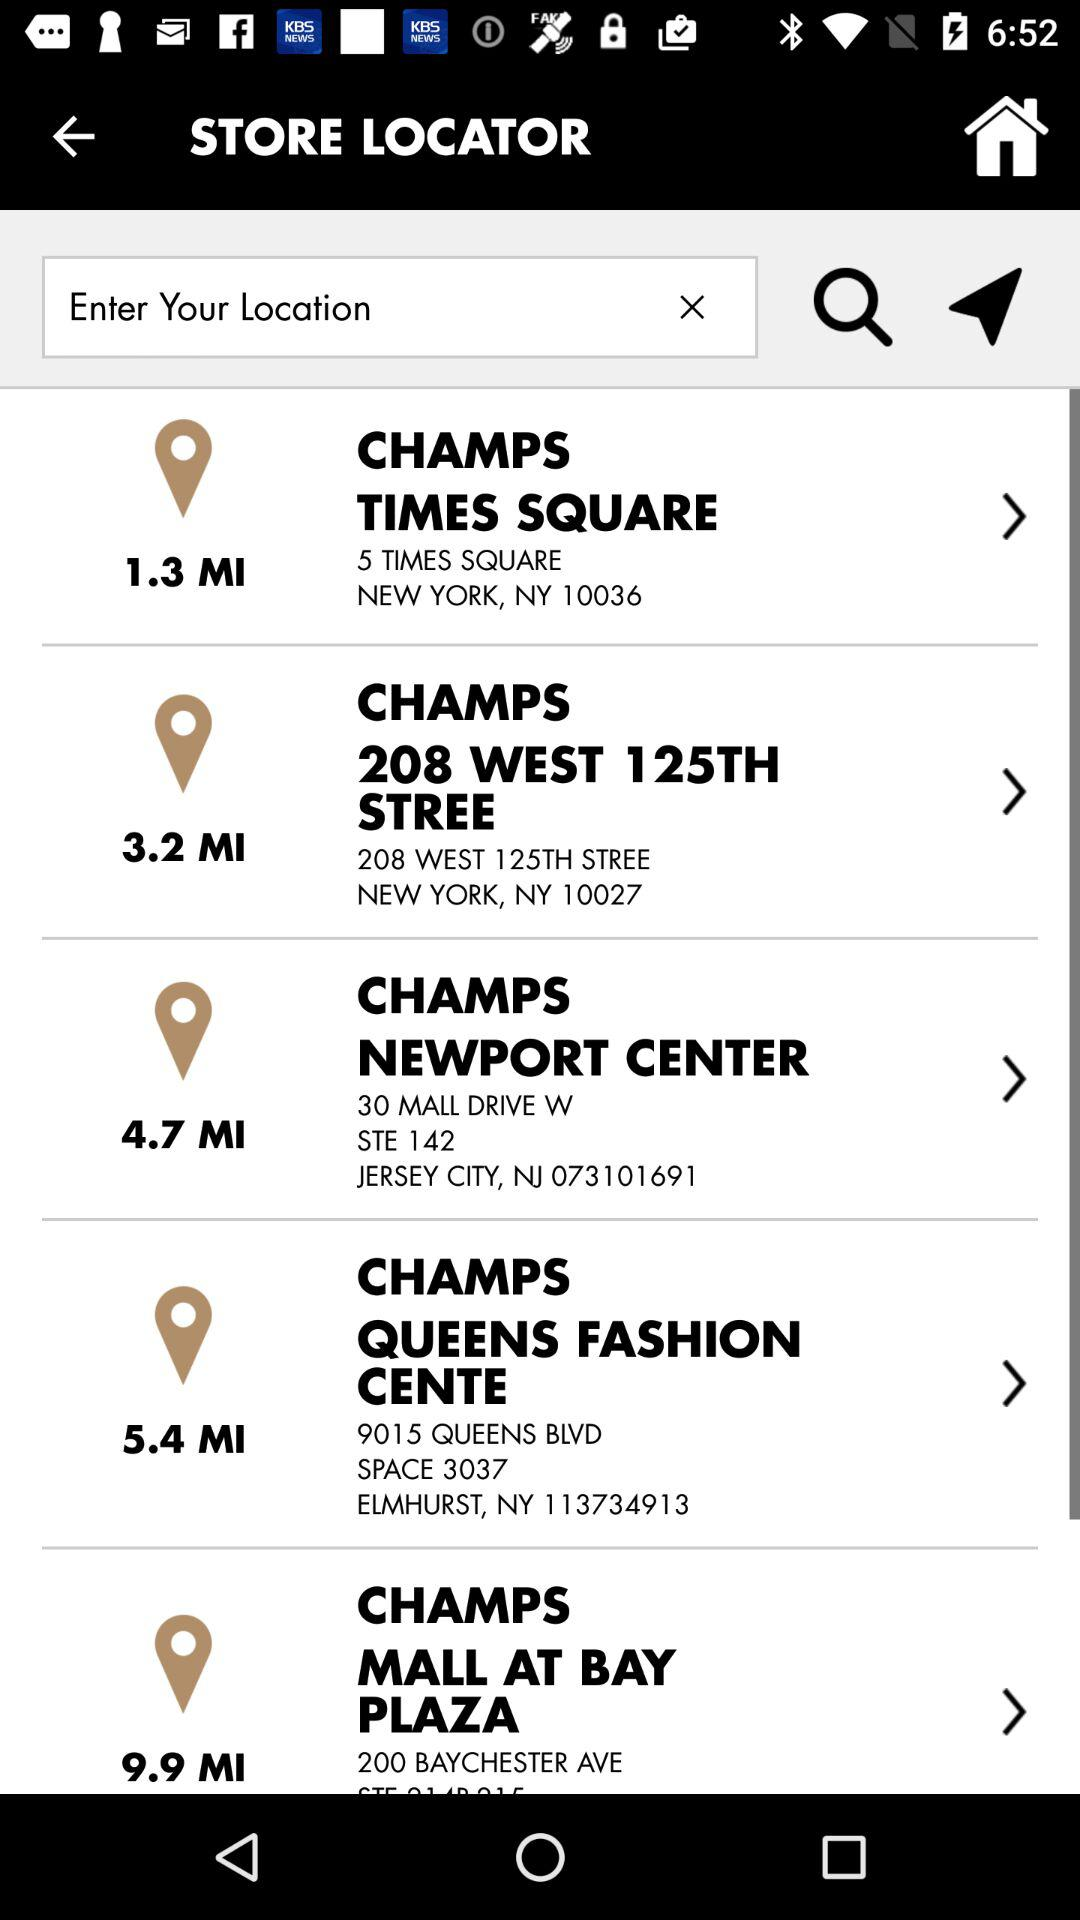What location is entered into the search bar?
When the provided information is insufficient, respond with <no answer>. <no answer> 